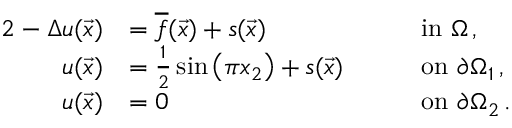Convert formula to latex. <formula><loc_0><loc_0><loc_500><loc_500>\begin{array} { r l r l } { { 2 } - \Delta u ( \vec { x } ) } & { = \overline { f } ( \vec { x } ) + s ( \vec { x } ) \quad } & & { i n \Omega \, , } \\ { u ( \vec { x } ) } & { = \frac { 1 } { 2 } \sin \left ( \pi x _ { 2 } \right ) + s ( \vec { x } ) \quad } & & { o n \partial \Omega _ { 1 } \, , } \\ { u ( \vec { x } ) } & { = 0 \quad } & & { o n \partial \Omega _ { 2 } \, . } \end{array}</formula> 